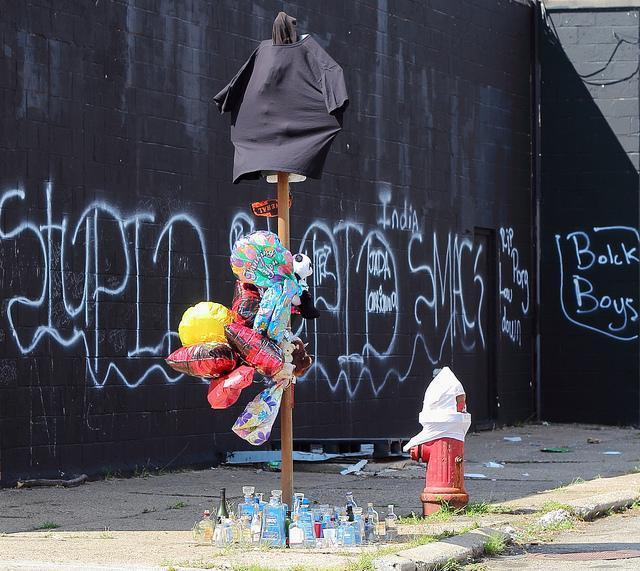How many fire hydrants are visible?
Give a very brief answer. 1. How many people are smiling?
Give a very brief answer. 0. 